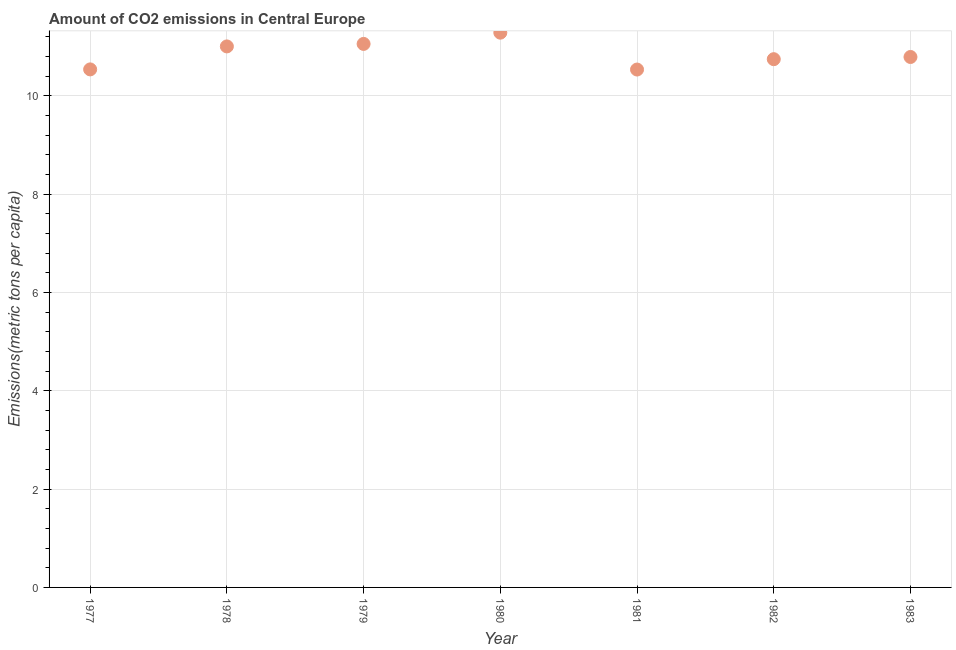What is the amount of co2 emissions in 1982?
Make the answer very short. 10.75. Across all years, what is the maximum amount of co2 emissions?
Offer a terse response. 11.29. Across all years, what is the minimum amount of co2 emissions?
Offer a terse response. 10.54. In which year was the amount of co2 emissions maximum?
Make the answer very short. 1980. What is the sum of the amount of co2 emissions?
Offer a very short reply. 75.96. What is the difference between the amount of co2 emissions in 1979 and 1983?
Your answer should be very brief. 0.27. What is the average amount of co2 emissions per year?
Your answer should be compact. 10.85. What is the median amount of co2 emissions?
Ensure brevity in your answer.  10.79. In how many years, is the amount of co2 emissions greater than 0.8 metric tons per capita?
Your response must be concise. 7. Do a majority of the years between 1979 and 1980 (inclusive) have amount of co2 emissions greater than 7.2 metric tons per capita?
Provide a succinct answer. Yes. What is the ratio of the amount of co2 emissions in 1978 to that in 1981?
Keep it short and to the point. 1.04. Is the amount of co2 emissions in 1979 less than that in 1983?
Offer a very short reply. No. Is the difference between the amount of co2 emissions in 1980 and 1981 greater than the difference between any two years?
Provide a succinct answer. Yes. What is the difference between the highest and the second highest amount of co2 emissions?
Keep it short and to the point. 0.23. Is the sum of the amount of co2 emissions in 1981 and 1983 greater than the maximum amount of co2 emissions across all years?
Make the answer very short. Yes. What is the difference between the highest and the lowest amount of co2 emissions?
Make the answer very short. 0.75. Does the amount of co2 emissions monotonically increase over the years?
Your answer should be very brief. No. How many years are there in the graph?
Make the answer very short. 7. What is the difference between two consecutive major ticks on the Y-axis?
Your answer should be very brief. 2. Are the values on the major ticks of Y-axis written in scientific E-notation?
Your response must be concise. No. Does the graph contain any zero values?
Provide a succinct answer. No. Does the graph contain grids?
Keep it short and to the point. Yes. What is the title of the graph?
Offer a terse response. Amount of CO2 emissions in Central Europe. What is the label or title of the X-axis?
Offer a very short reply. Year. What is the label or title of the Y-axis?
Your response must be concise. Emissions(metric tons per capita). What is the Emissions(metric tons per capita) in 1977?
Your answer should be compact. 10.54. What is the Emissions(metric tons per capita) in 1978?
Make the answer very short. 11.01. What is the Emissions(metric tons per capita) in 1979?
Keep it short and to the point. 11.06. What is the Emissions(metric tons per capita) in 1980?
Offer a very short reply. 11.29. What is the Emissions(metric tons per capita) in 1981?
Offer a terse response. 10.54. What is the Emissions(metric tons per capita) in 1982?
Give a very brief answer. 10.75. What is the Emissions(metric tons per capita) in 1983?
Your response must be concise. 10.79. What is the difference between the Emissions(metric tons per capita) in 1977 and 1978?
Offer a very short reply. -0.47. What is the difference between the Emissions(metric tons per capita) in 1977 and 1979?
Make the answer very short. -0.52. What is the difference between the Emissions(metric tons per capita) in 1977 and 1980?
Ensure brevity in your answer.  -0.75. What is the difference between the Emissions(metric tons per capita) in 1977 and 1981?
Provide a short and direct response. 0. What is the difference between the Emissions(metric tons per capita) in 1977 and 1982?
Your answer should be very brief. -0.21. What is the difference between the Emissions(metric tons per capita) in 1977 and 1983?
Ensure brevity in your answer.  -0.25. What is the difference between the Emissions(metric tons per capita) in 1978 and 1979?
Provide a short and direct response. -0.05. What is the difference between the Emissions(metric tons per capita) in 1978 and 1980?
Offer a terse response. -0.28. What is the difference between the Emissions(metric tons per capita) in 1978 and 1981?
Offer a terse response. 0.47. What is the difference between the Emissions(metric tons per capita) in 1978 and 1982?
Provide a short and direct response. 0.26. What is the difference between the Emissions(metric tons per capita) in 1978 and 1983?
Provide a short and direct response. 0.22. What is the difference between the Emissions(metric tons per capita) in 1979 and 1980?
Provide a succinct answer. -0.23. What is the difference between the Emissions(metric tons per capita) in 1979 and 1981?
Your answer should be very brief. 0.52. What is the difference between the Emissions(metric tons per capita) in 1979 and 1982?
Ensure brevity in your answer.  0.31. What is the difference between the Emissions(metric tons per capita) in 1979 and 1983?
Offer a very short reply. 0.27. What is the difference between the Emissions(metric tons per capita) in 1980 and 1981?
Provide a succinct answer. 0.75. What is the difference between the Emissions(metric tons per capita) in 1980 and 1982?
Keep it short and to the point. 0.54. What is the difference between the Emissions(metric tons per capita) in 1980 and 1983?
Ensure brevity in your answer.  0.49. What is the difference between the Emissions(metric tons per capita) in 1981 and 1982?
Provide a succinct answer. -0.21. What is the difference between the Emissions(metric tons per capita) in 1981 and 1983?
Provide a short and direct response. -0.26. What is the difference between the Emissions(metric tons per capita) in 1982 and 1983?
Provide a succinct answer. -0.04. What is the ratio of the Emissions(metric tons per capita) in 1977 to that in 1978?
Your answer should be compact. 0.96. What is the ratio of the Emissions(metric tons per capita) in 1977 to that in 1979?
Your answer should be very brief. 0.95. What is the ratio of the Emissions(metric tons per capita) in 1977 to that in 1980?
Ensure brevity in your answer.  0.93. What is the ratio of the Emissions(metric tons per capita) in 1977 to that in 1981?
Keep it short and to the point. 1. What is the ratio of the Emissions(metric tons per capita) in 1978 to that in 1979?
Your response must be concise. 0.99. What is the ratio of the Emissions(metric tons per capita) in 1978 to that in 1981?
Provide a succinct answer. 1.04. What is the ratio of the Emissions(metric tons per capita) in 1978 to that in 1983?
Your answer should be compact. 1.02. What is the ratio of the Emissions(metric tons per capita) in 1979 to that in 1980?
Keep it short and to the point. 0.98. What is the ratio of the Emissions(metric tons per capita) in 1979 to that in 1981?
Keep it short and to the point. 1.05. What is the ratio of the Emissions(metric tons per capita) in 1979 to that in 1982?
Make the answer very short. 1.03. What is the ratio of the Emissions(metric tons per capita) in 1980 to that in 1981?
Offer a terse response. 1.07. What is the ratio of the Emissions(metric tons per capita) in 1980 to that in 1983?
Your answer should be very brief. 1.05. What is the ratio of the Emissions(metric tons per capita) in 1981 to that in 1983?
Provide a short and direct response. 0.98. 